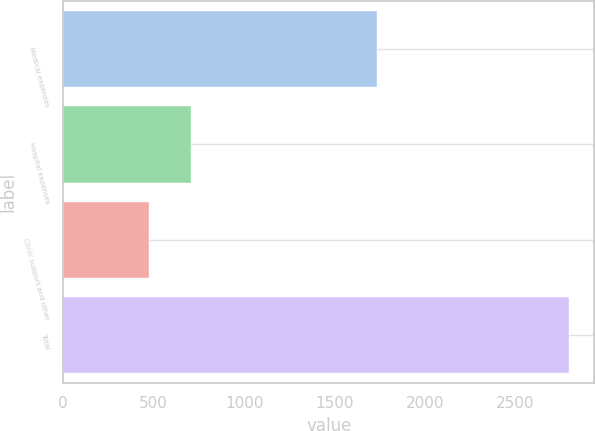Convert chart. <chart><loc_0><loc_0><loc_500><loc_500><bar_chart><fcel>Medical expenses<fcel>Hospital expenses<fcel>Clinic support and other<fcel>Total<nl><fcel>1734<fcel>708<fcel>476<fcel>2796<nl></chart> 